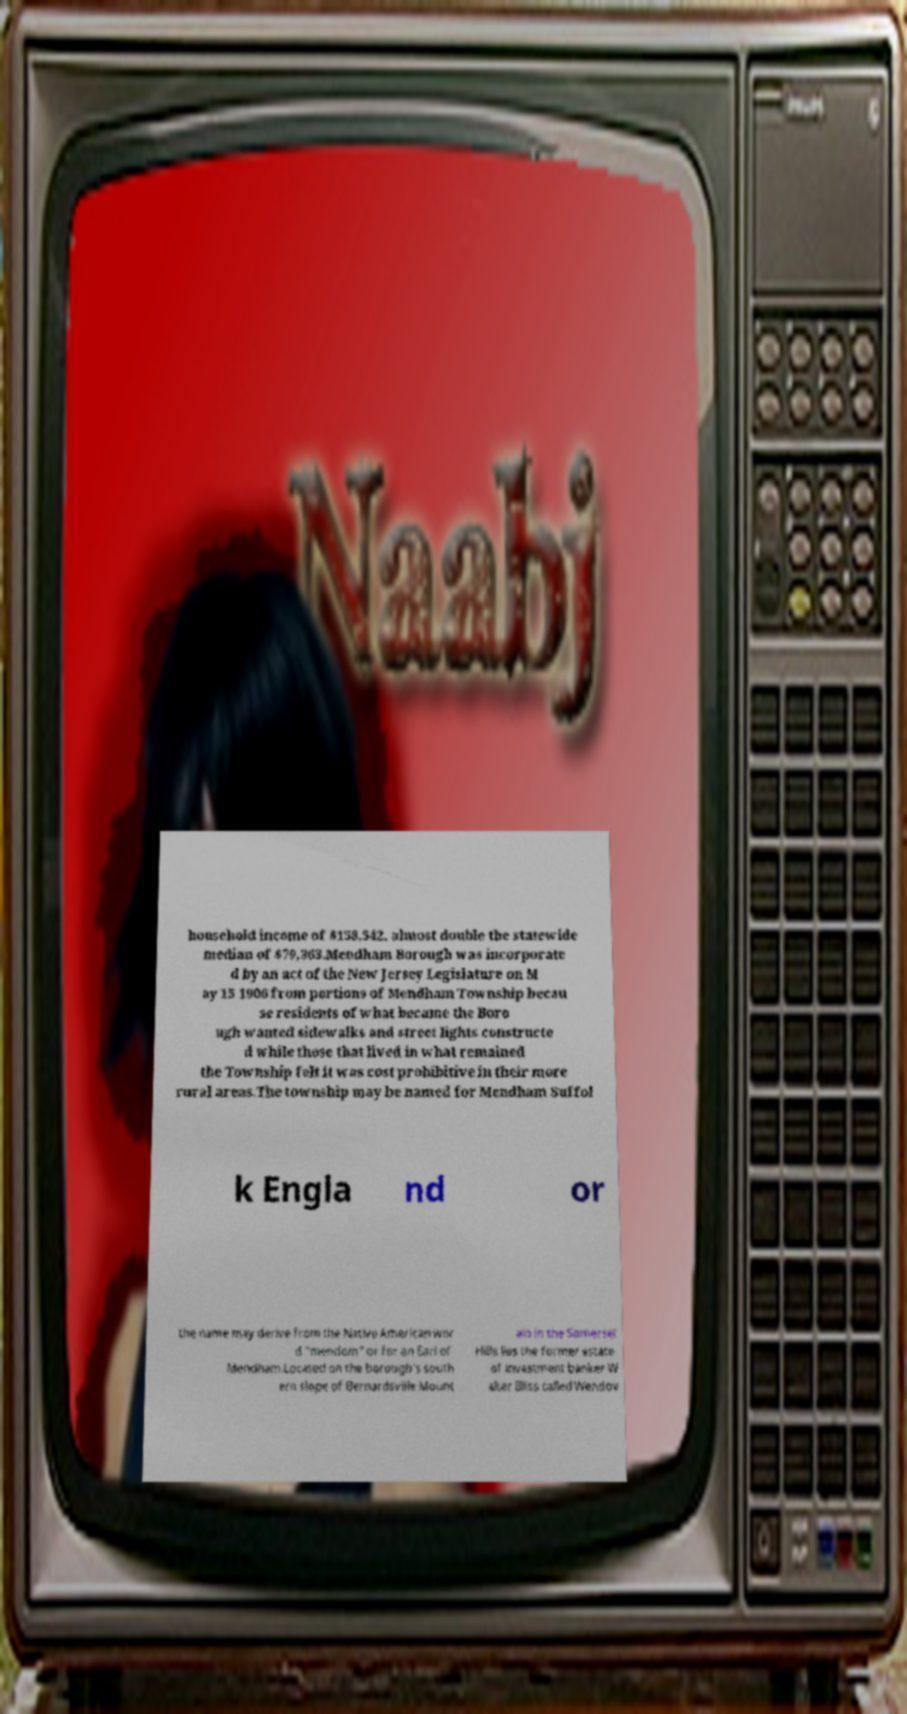For documentation purposes, I need the text within this image transcribed. Could you provide that? household income of $158,542, almost double the statewide median of $79,363.Mendham Borough was incorporate d by an act of the New Jersey Legislature on M ay 15 1906 from portions of Mendham Township becau se residents of what became the Boro ugh wanted sidewalks and street lights constructe d while those that lived in what remained the Township felt it was cost prohibitive in their more rural areas.The township may be named for Mendham Suffol k Engla nd or the name may derive from the Native American wor d "mendom" or for an Earl of Mendham.Located on the borough's south ern slope of Bernardsville Mount ain in the Somerset Hills lies the former estate of investment banker W alter Bliss called Wendov 